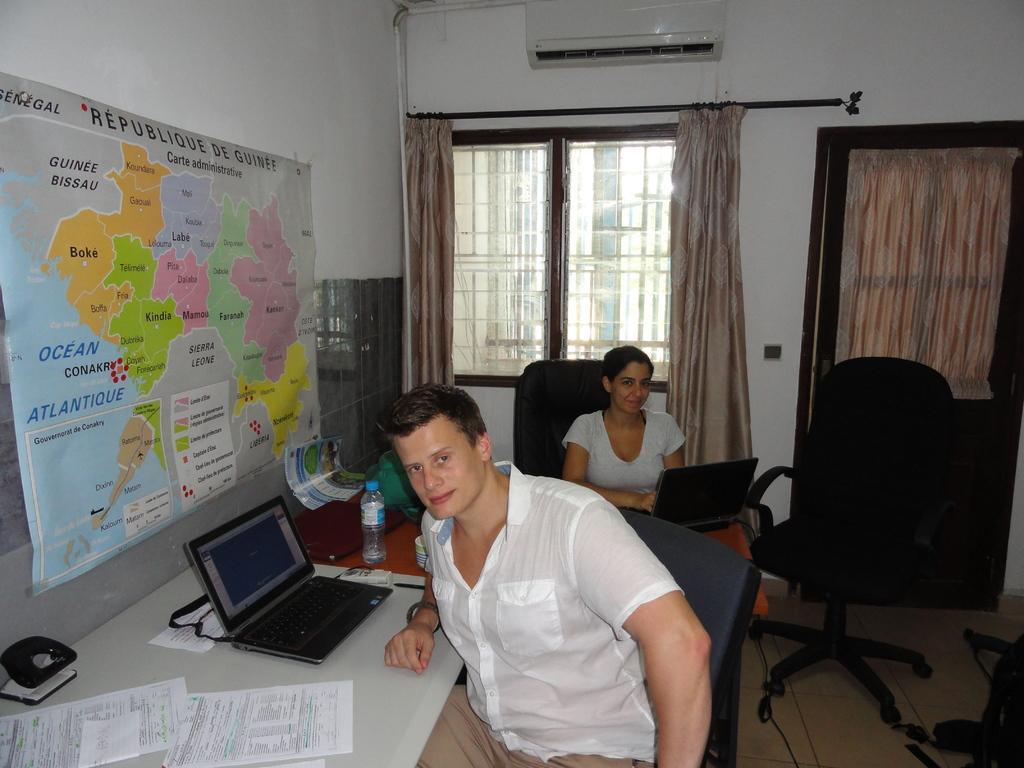How would you summarize this image in a sentence or two? In this picture there are two people those who are sitting on the chairs, facing towards the front direction, the boy who is sitting at the center of the image having a laptop and there is another laptop on the lap of lady and there is a poster of maps at the left side of the image and there is a door at the center of the image. 